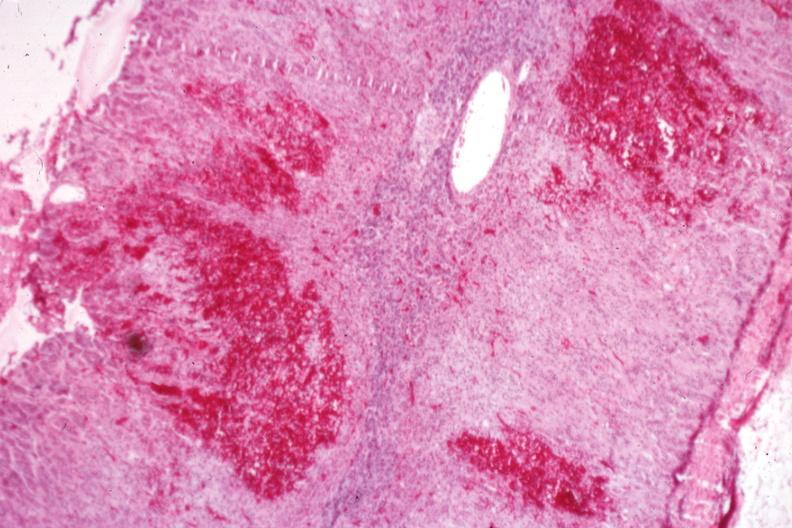does liver show multiple cortical hemorrhages which may be the early stage of a gross adrenal hemorrhage?
Answer the question using a single word or phrase. No 